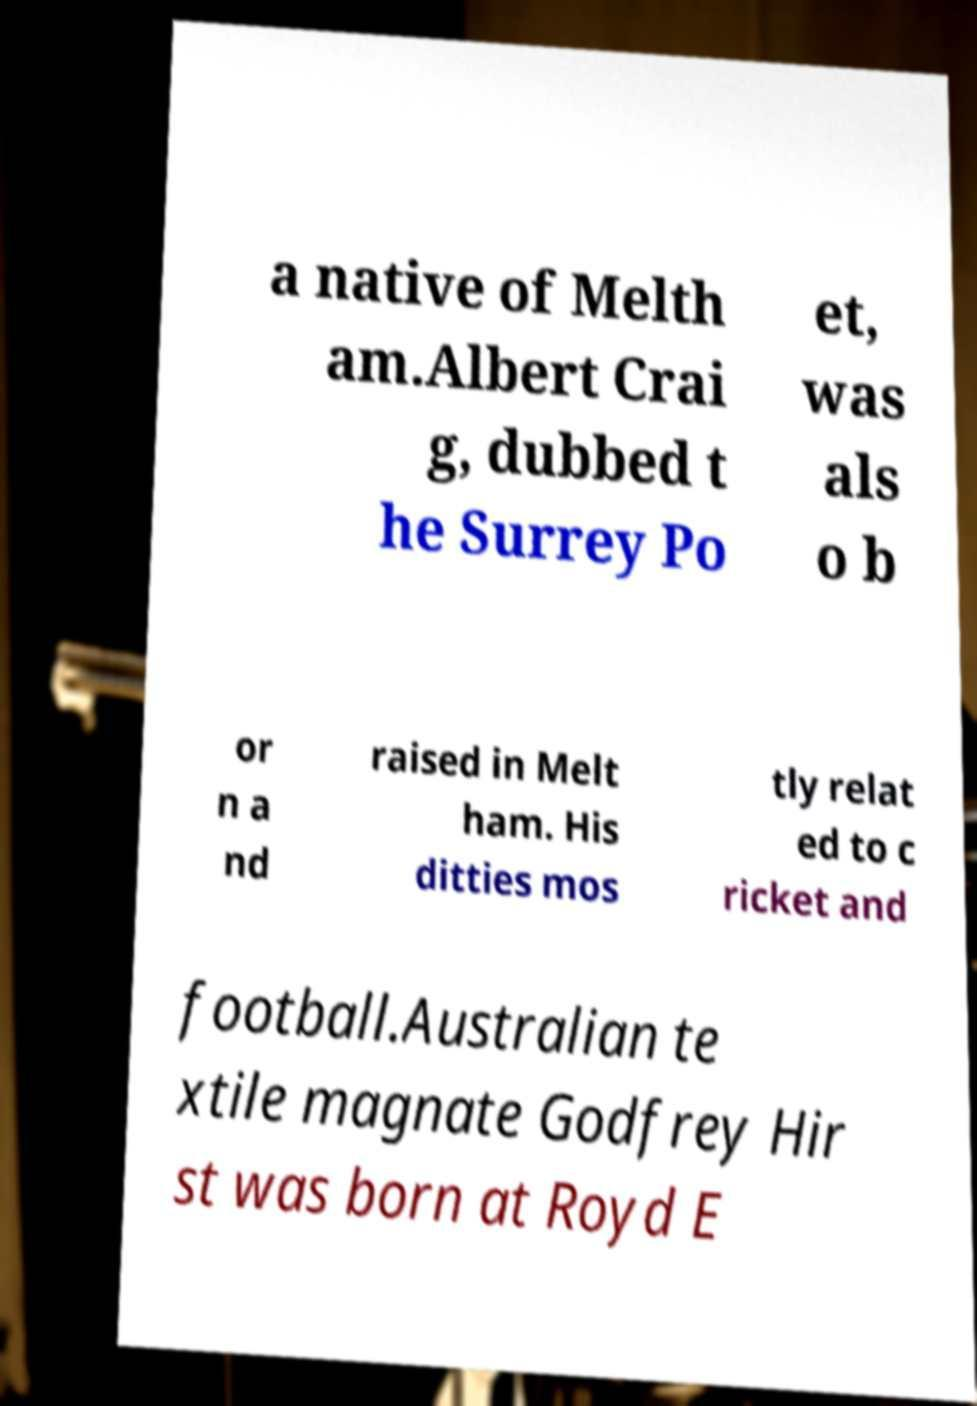Please read and relay the text visible in this image. What does it say? a native of Melth am.Albert Crai g, dubbed t he Surrey Po et, was als o b or n a nd raised in Melt ham. His ditties mos tly relat ed to c ricket and football.Australian te xtile magnate Godfrey Hir st was born at Royd E 